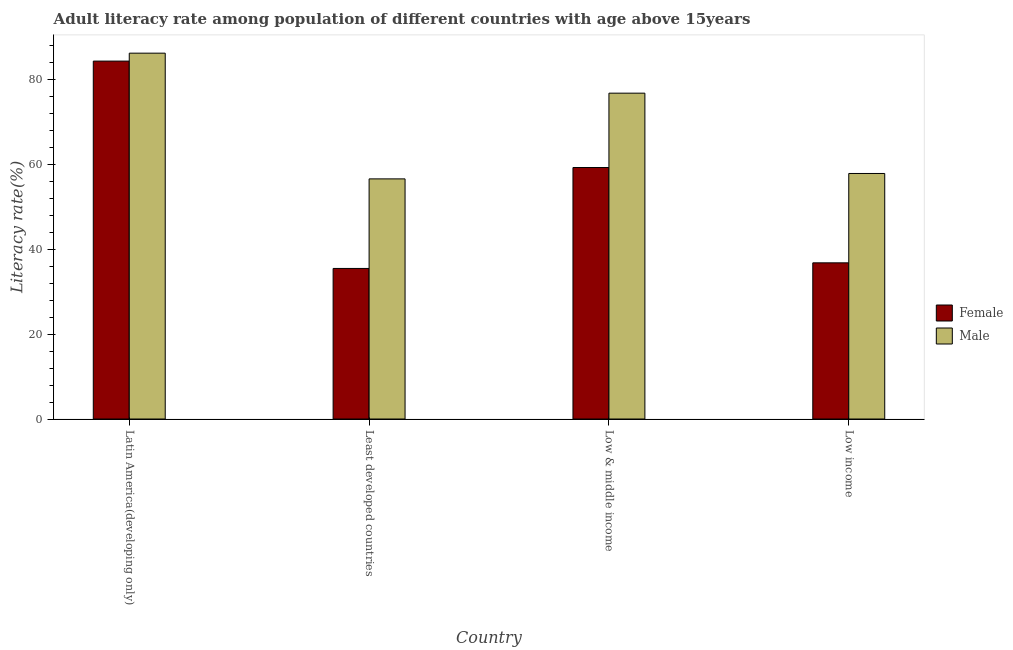How many different coloured bars are there?
Your answer should be very brief. 2. Are the number of bars on each tick of the X-axis equal?
Offer a terse response. Yes. How many bars are there on the 2nd tick from the left?
Keep it short and to the point. 2. How many bars are there on the 1st tick from the right?
Offer a very short reply. 2. What is the label of the 1st group of bars from the left?
Provide a succinct answer. Latin America(developing only). What is the male adult literacy rate in Low income?
Provide a succinct answer. 57.84. Across all countries, what is the maximum female adult literacy rate?
Give a very brief answer. 84.32. Across all countries, what is the minimum female adult literacy rate?
Keep it short and to the point. 35.47. In which country was the female adult literacy rate maximum?
Offer a terse response. Latin America(developing only). In which country was the male adult literacy rate minimum?
Provide a succinct answer. Least developed countries. What is the total male adult literacy rate in the graph?
Your answer should be compact. 277.36. What is the difference between the male adult literacy rate in Least developed countries and that in Low & middle income?
Your answer should be compact. -20.19. What is the difference between the female adult literacy rate in Low income and the male adult literacy rate in Least developed countries?
Your answer should be very brief. -19.78. What is the average male adult literacy rate per country?
Your response must be concise. 69.34. What is the difference between the female adult literacy rate and male adult literacy rate in Latin America(developing only)?
Ensure brevity in your answer.  -1.87. What is the ratio of the male adult literacy rate in Low & middle income to that in Low income?
Give a very brief answer. 1.33. Is the female adult literacy rate in Latin America(developing only) less than that in Low & middle income?
Make the answer very short. No. Is the difference between the female adult literacy rate in Latin America(developing only) and Low & middle income greater than the difference between the male adult literacy rate in Latin America(developing only) and Low & middle income?
Ensure brevity in your answer.  Yes. What is the difference between the highest and the second highest female adult literacy rate?
Offer a terse response. 25.07. What is the difference between the highest and the lowest male adult literacy rate?
Offer a very short reply. 29.62. What does the 2nd bar from the left in Low & middle income represents?
Provide a succinct answer. Male. What does the 2nd bar from the right in Latin America(developing only) represents?
Keep it short and to the point. Female. Does the graph contain any zero values?
Give a very brief answer. No. How many legend labels are there?
Ensure brevity in your answer.  2. What is the title of the graph?
Keep it short and to the point. Adult literacy rate among population of different countries with age above 15years. What is the label or title of the X-axis?
Offer a terse response. Country. What is the label or title of the Y-axis?
Your answer should be very brief. Literacy rate(%). What is the Literacy rate(%) in Female in Latin America(developing only)?
Offer a very short reply. 84.32. What is the Literacy rate(%) of Male in Latin America(developing only)?
Offer a very short reply. 86.19. What is the Literacy rate(%) of Female in Least developed countries?
Your answer should be compact. 35.47. What is the Literacy rate(%) in Male in Least developed countries?
Your response must be concise. 56.57. What is the Literacy rate(%) of Female in Low & middle income?
Keep it short and to the point. 59.25. What is the Literacy rate(%) of Male in Low & middle income?
Ensure brevity in your answer.  76.76. What is the Literacy rate(%) in Female in Low income?
Keep it short and to the point. 36.79. What is the Literacy rate(%) in Male in Low income?
Your response must be concise. 57.84. Across all countries, what is the maximum Literacy rate(%) in Female?
Give a very brief answer. 84.32. Across all countries, what is the maximum Literacy rate(%) of Male?
Your response must be concise. 86.19. Across all countries, what is the minimum Literacy rate(%) in Female?
Give a very brief answer. 35.47. Across all countries, what is the minimum Literacy rate(%) in Male?
Provide a short and direct response. 56.57. What is the total Literacy rate(%) of Female in the graph?
Your response must be concise. 215.83. What is the total Literacy rate(%) of Male in the graph?
Your response must be concise. 277.36. What is the difference between the Literacy rate(%) in Female in Latin America(developing only) and that in Least developed countries?
Your answer should be compact. 48.85. What is the difference between the Literacy rate(%) of Male in Latin America(developing only) and that in Least developed countries?
Your answer should be very brief. 29.62. What is the difference between the Literacy rate(%) in Female in Latin America(developing only) and that in Low & middle income?
Make the answer very short. 25.07. What is the difference between the Literacy rate(%) in Male in Latin America(developing only) and that in Low & middle income?
Offer a very short reply. 9.42. What is the difference between the Literacy rate(%) of Female in Latin America(developing only) and that in Low income?
Your answer should be very brief. 47.52. What is the difference between the Literacy rate(%) of Male in Latin America(developing only) and that in Low income?
Keep it short and to the point. 28.34. What is the difference between the Literacy rate(%) in Female in Least developed countries and that in Low & middle income?
Offer a very short reply. -23.78. What is the difference between the Literacy rate(%) in Male in Least developed countries and that in Low & middle income?
Your answer should be very brief. -20.19. What is the difference between the Literacy rate(%) of Female in Least developed countries and that in Low income?
Offer a terse response. -1.32. What is the difference between the Literacy rate(%) in Male in Least developed countries and that in Low income?
Your answer should be very brief. -1.27. What is the difference between the Literacy rate(%) of Female in Low & middle income and that in Low income?
Give a very brief answer. 22.45. What is the difference between the Literacy rate(%) of Male in Low & middle income and that in Low income?
Offer a terse response. 18.92. What is the difference between the Literacy rate(%) of Female in Latin America(developing only) and the Literacy rate(%) of Male in Least developed countries?
Make the answer very short. 27.75. What is the difference between the Literacy rate(%) of Female in Latin America(developing only) and the Literacy rate(%) of Male in Low & middle income?
Offer a very short reply. 7.55. What is the difference between the Literacy rate(%) of Female in Latin America(developing only) and the Literacy rate(%) of Male in Low income?
Provide a succinct answer. 26.48. What is the difference between the Literacy rate(%) of Female in Least developed countries and the Literacy rate(%) of Male in Low & middle income?
Keep it short and to the point. -41.29. What is the difference between the Literacy rate(%) of Female in Least developed countries and the Literacy rate(%) of Male in Low income?
Give a very brief answer. -22.37. What is the difference between the Literacy rate(%) of Female in Low & middle income and the Literacy rate(%) of Male in Low income?
Provide a succinct answer. 1.4. What is the average Literacy rate(%) in Female per country?
Offer a very short reply. 53.96. What is the average Literacy rate(%) of Male per country?
Your response must be concise. 69.34. What is the difference between the Literacy rate(%) of Female and Literacy rate(%) of Male in Latin America(developing only)?
Your answer should be very brief. -1.87. What is the difference between the Literacy rate(%) in Female and Literacy rate(%) in Male in Least developed countries?
Offer a very short reply. -21.1. What is the difference between the Literacy rate(%) in Female and Literacy rate(%) in Male in Low & middle income?
Ensure brevity in your answer.  -17.52. What is the difference between the Literacy rate(%) in Female and Literacy rate(%) in Male in Low income?
Ensure brevity in your answer.  -21.05. What is the ratio of the Literacy rate(%) in Female in Latin America(developing only) to that in Least developed countries?
Ensure brevity in your answer.  2.38. What is the ratio of the Literacy rate(%) in Male in Latin America(developing only) to that in Least developed countries?
Your response must be concise. 1.52. What is the ratio of the Literacy rate(%) in Female in Latin America(developing only) to that in Low & middle income?
Ensure brevity in your answer.  1.42. What is the ratio of the Literacy rate(%) of Male in Latin America(developing only) to that in Low & middle income?
Offer a terse response. 1.12. What is the ratio of the Literacy rate(%) of Female in Latin America(developing only) to that in Low income?
Ensure brevity in your answer.  2.29. What is the ratio of the Literacy rate(%) in Male in Latin America(developing only) to that in Low income?
Ensure brevity in your answer.  1.49. What is the ratio of the Literacy rate(%) in Female in Least developed countries to that in Low & middle income?
Your answer should be compact. 0.6. What is the ratio of the Literacy rate(%) of Male in Least developed countries to that in Low & middle income?
Provide a succinct answer. 0.74. What is the ratio of the Literacy rate(%) of Female in Least developed countries to that in Low income?
Provide a short and direct response. 0.96. What is the ratio of the Literacy rate(%) in Male in Least developed countries to that in Low income?
Provide a short and direct response. 0.98. What is the ratio of the Literacy rate(%) of Female in Low & middle income to that in Low income?
Provide a succinct answer. 1.61. What is the ratio of the Literacy rate(%) in Male in Low & middle income to that in Low income?
Keep it short and to the point. 1.33. What is the difference between the highest and the second highest Literacy rate(%) of Female?
Give a very brief answer. 25.07. What is the difference between the highest and the second highest Literacy rate(%) in Male?
Offer a terse response. 9.42. What is the difference between the highest and the lowest Literacy rate(%) of Female?
Provide a succinct answer. 48.85. What is the difference between the highest and the lowest Literacy rate(%) in Male?
Your answer should be compact. 29.62. 